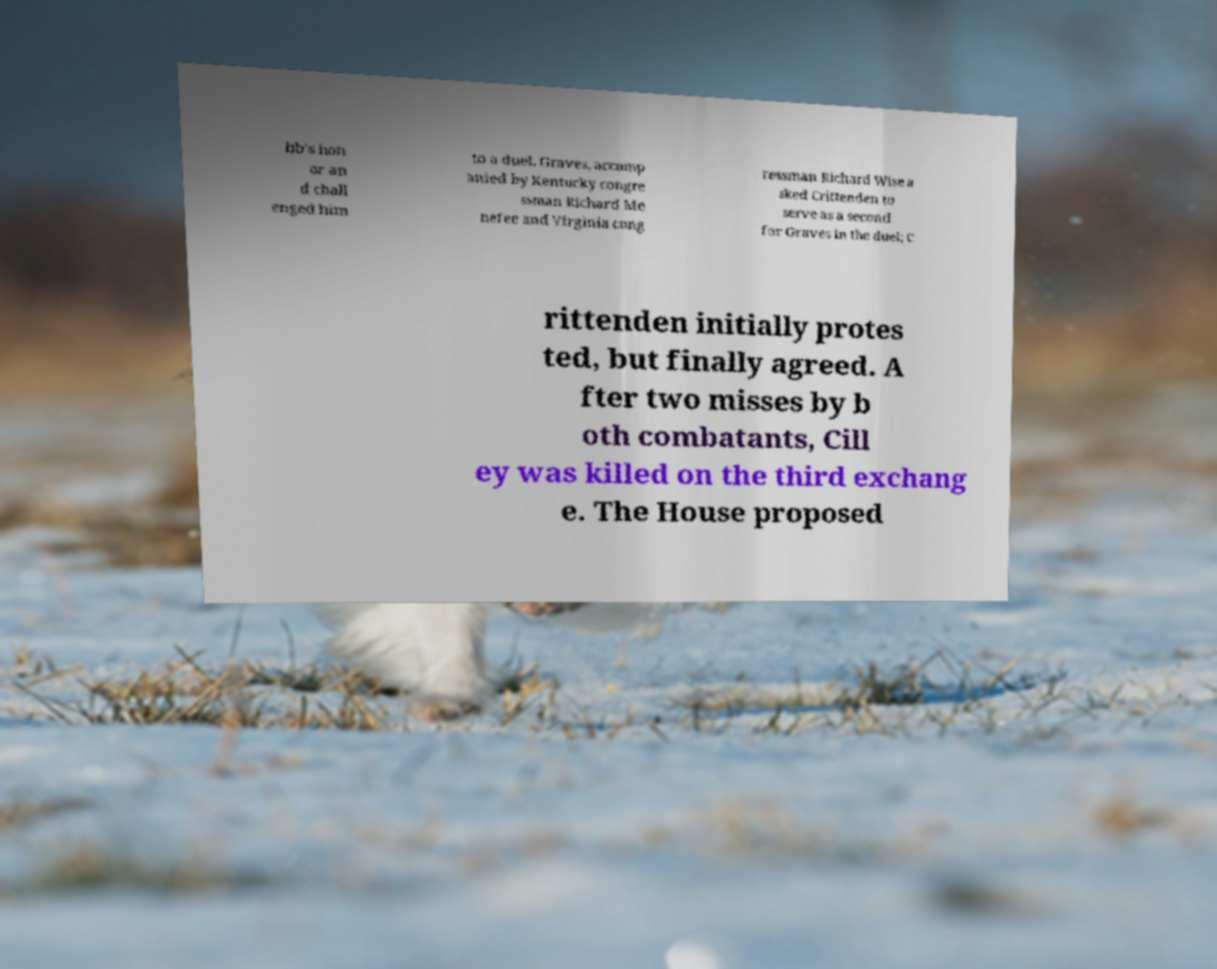Can you read and provide the text displayed in the image?This photo seems to have some interesting text. Can you extract and type it out for me? bb's hon or an d chall enged him to a duel. Graves, accomp anied by Kentucky congre ssman Richard Me nefee and Virginia cong ressman Richard Wise a sked Crittenden to serve as a second for Graves in the duel; C rittenden initially protes ted, but finally agreed. A fter two misses by b oth combatants, Cill ey was killed on the third exchang e. The House proposed 